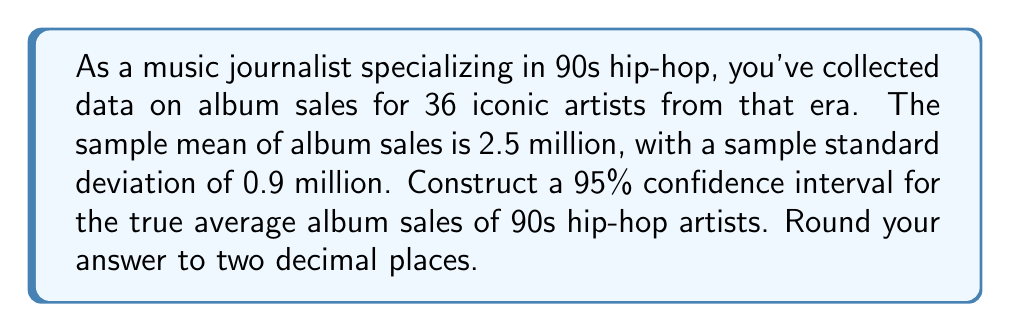Could you help me with this problem? To construct a 95% confidence interval, we'll follow these steps:

1) The formula for a confidence interval is:

   $$\bar{x} \pm t_{\alpha/2, n-1} \cdot \frac{s}{\sqrt{n}}$$

   Where:
   $\bar{x}$ is the sample mean
   $t_{\alpha/2, n-1}$ is the t-value for a 95% confidence level with n-1 degrees of freedom
   $s$ is the sample standard deviation
   $n$ is the sample size

2) We know:
   $\bar{x} = 2.5$ million
   $s = 0.9$ million
   $n = 36$
   Confidence level = 95%, so $\alpha = 0.05$

3) Degrees of freedom = $n - 1 = 36 - 1 = 35$

4) From a t-table or calculator, we find $t_{0.025, 35} \approx 2.030$

5) Now we can calculate the margin of error:

   $$2.030 \cdot \frac{0.9}{\sqrt{36}} \approx 0.305$$

6) Therefore, the confidence interval is:

   $$2.5 \pm 0.305$$

7) This gives us:
   Lower bound: $2.5 - 0.305 = 2.195$
   Upper bound: $2.5 + 0.305 = 2.805$

8) Rounding to two decimal places:
   (2.20, 2.81)
Answer: (2.20, 2.81) million albums 